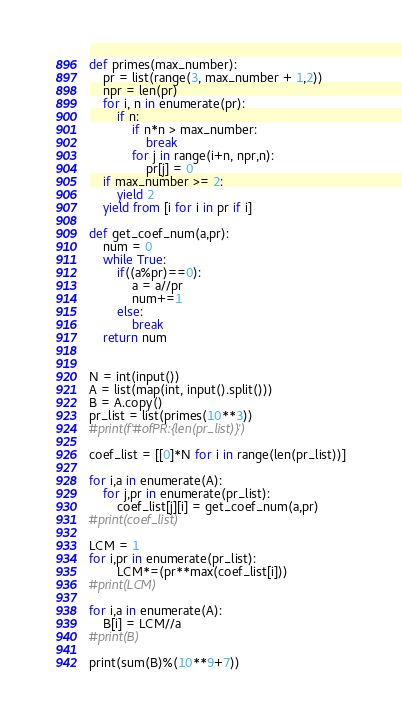Convert code to text. <code><loc_0><loc_0><loc_500><loc_500><_Python_>def primes(max_number):
    pr = list(range(3, max_number + 1,2))
    npr = len(pr)
    for i, n in enumerate(pr):
        if n:
            if n*n > max_number:
                break
            for j in range(i+n, npr,n):
                pr[j] = 0
    if max_number >= 2:
        yield 2
    yield from [i for i in pr if i]

def get_coef_num(a,pr):
    num = 0
    while True:
        if((a%pr)==0):
            a = a//pr
            num+=1
        else:
            break
    return num


N = int(input())
A = list(map(int, input().split()))
B = A.copy()
pr_list = list(primes(10**3))
#print(f'#ofPR:{len(pr_list)}')

coef_list = [[0]*N for i in range(len(pr_list))]

for i,a in enumerate(A):
    for j,pr in enumerate(pr_list):
        coef_list[j][i] = get_coef_num(a,pr)
#print(coef_list)

LCM = 1
for i,pr in enumerate(pr_list):
        LCM*=(pr**max(coef_list[i]))
#print(LCM)

for i,a in enumerate(A):
    B[i] = LCM//a
#print(B)

print(sum(B)%(10**9+7))</code> 